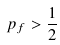Convert formula to latex. <formula><loc_0><loc_0><loc_500><loc_500>p _ { f } > \frac { 1 } { 2 }</formula> 